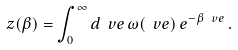Convert formula to latex. <formula><loc_0><loc_0><loc_500><loc_500>z ( \beta ) = \int _ { 0 } ^ { \infty } d \ v e \, \omega ( \ v e ) \, e ^ { - \beta \, \ v e } \, .</formula> 